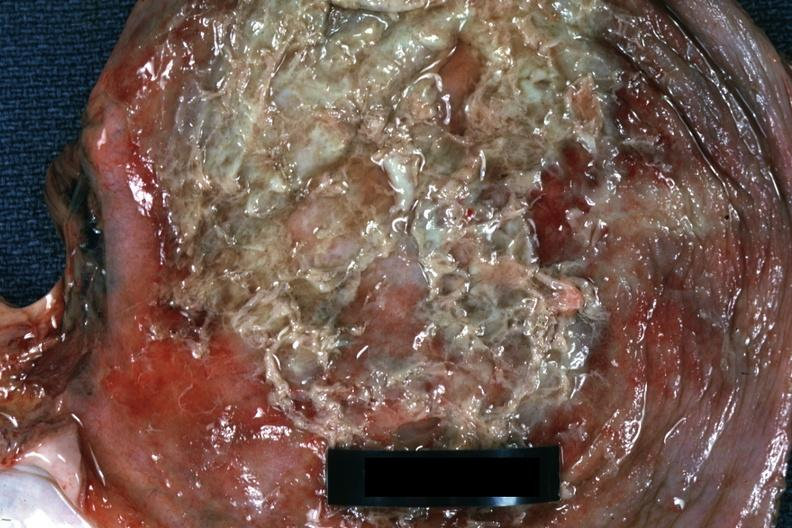s muscle present?
Answer the question using a single word or phrase. Yes 